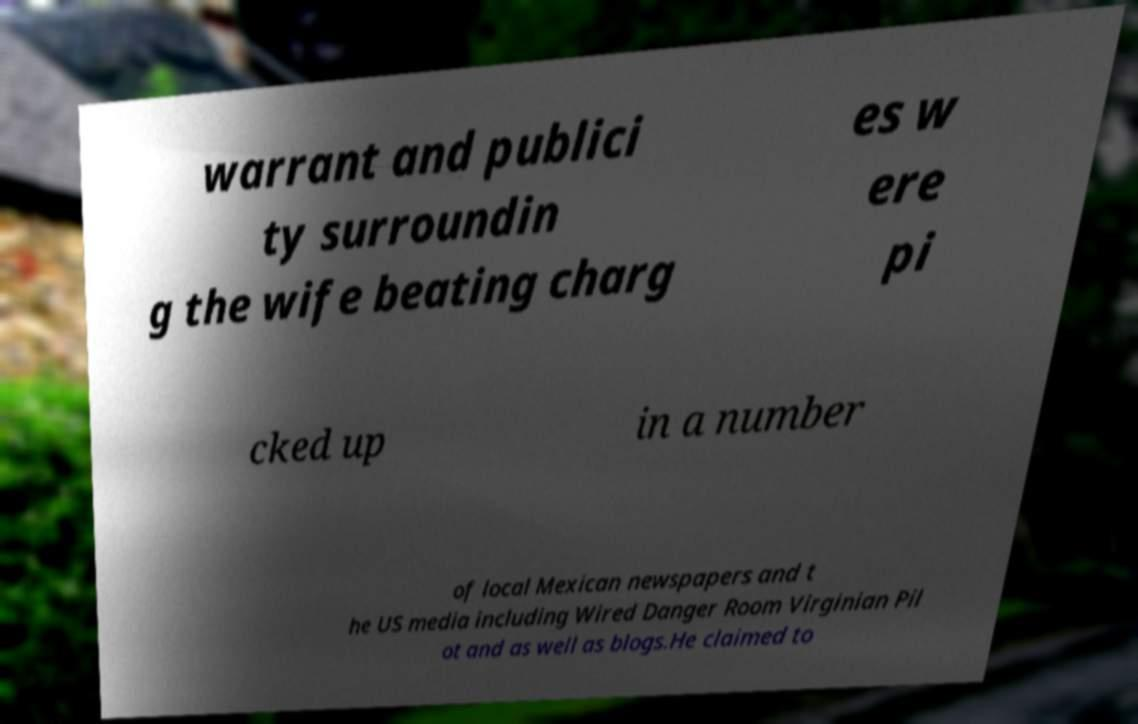Can you read and provide the text displayed in the image?This photo seems to have some interesting text. Can you extract and type it out for me? warrant and publici ty surroundin g the wife beating charg es w ere pi cked up in a number of local Mexican newspapers and t he US media including Wired Danger Room Virginian Pil ot and as well as blogs.He claimed to 